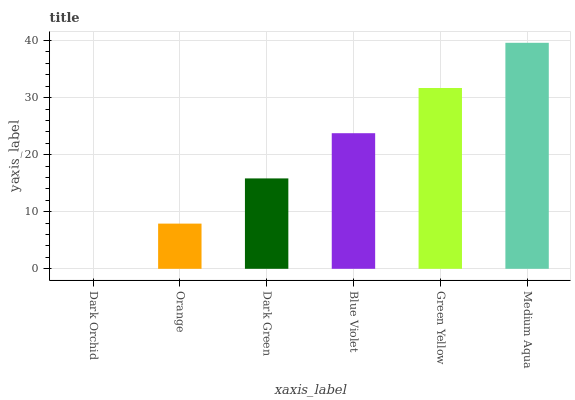Is Dark Orchid the minimum?
Answer yes or no. Yes. Is Medium Aqua the maximum?
Answer yes or no. Yes. Is Orange the minimum?
Answer yes or no. No. Is Orange the maximum?
Answer yes or no. No. Is Orange greater than Dark Orchid?
Answer yes or no. Yes. Is Dark Orchid less than Orange?
Answer yes or no. Yes. Is Dark Orchid greater than Orange?
Answer yes or no. No. Is Orange less than Dark Orchid?
Answer yes or no. No. Is Blue Violet the high median?
Answer yes or no. Yes. Is Dark Green the low median?
Answer yes or no. Yes. Is Green Yellow the high median?
Answer yes or no. No. Is Dark Orchid the low median?
Answer yes or no. No. 